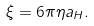<formula> <loc_0><loc_0><loc_500><loc_500>\xi = 6 \pi \eta a _ { H } .</formula> 